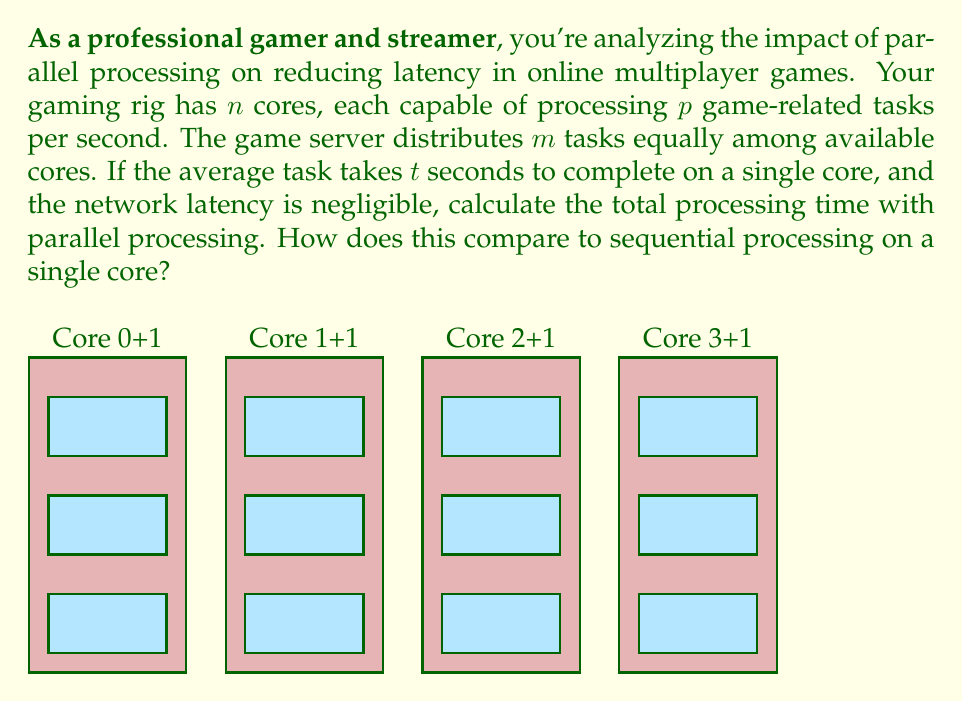Solve this math problem. Let's approach this step-by-step:

1) First, we need to calculate how many tasks each core will process:
   Tasks per core = $\frac{m}{n}$

2) Now, let's calculate how long it takes for one core to process its assigned tasks:
   Time per core = $\frac{m}{n} \cdot t$

3) Since all cores are working in parallel, the total processing time will be equal to the time taken by one core:
   Total parallel processing time = $\frac{m}{n} \cdot t$

4) For sequential processing on a single core, all $m$ tasks would be processed one after another:
   Sequential processing time = $m \cdot t$

5) To compare, we can calculate the speedup factor:
   Speedup = $\frac{\text{Sequential time}}{\text{Parallel time}} = \frac{m \cdot t}{\frac{m}{n} \cdot t} = n$

This means that parallel processing with $n$ cores is $n$ times faster than sequential processing on a single core.

6) We can express the total parallel processing time in terms of the sequential time:
   Total parallel processing time = $\frac{\text{Sequential time}}{n} = \frac{m \cdot t}{n}$

This formula gives us the total processing time with parallel processing, and shows how it compares to sequential processing.
Answer: $$\text{Total parallel processing time} = \frac{m \cdot t}{n}$$ 